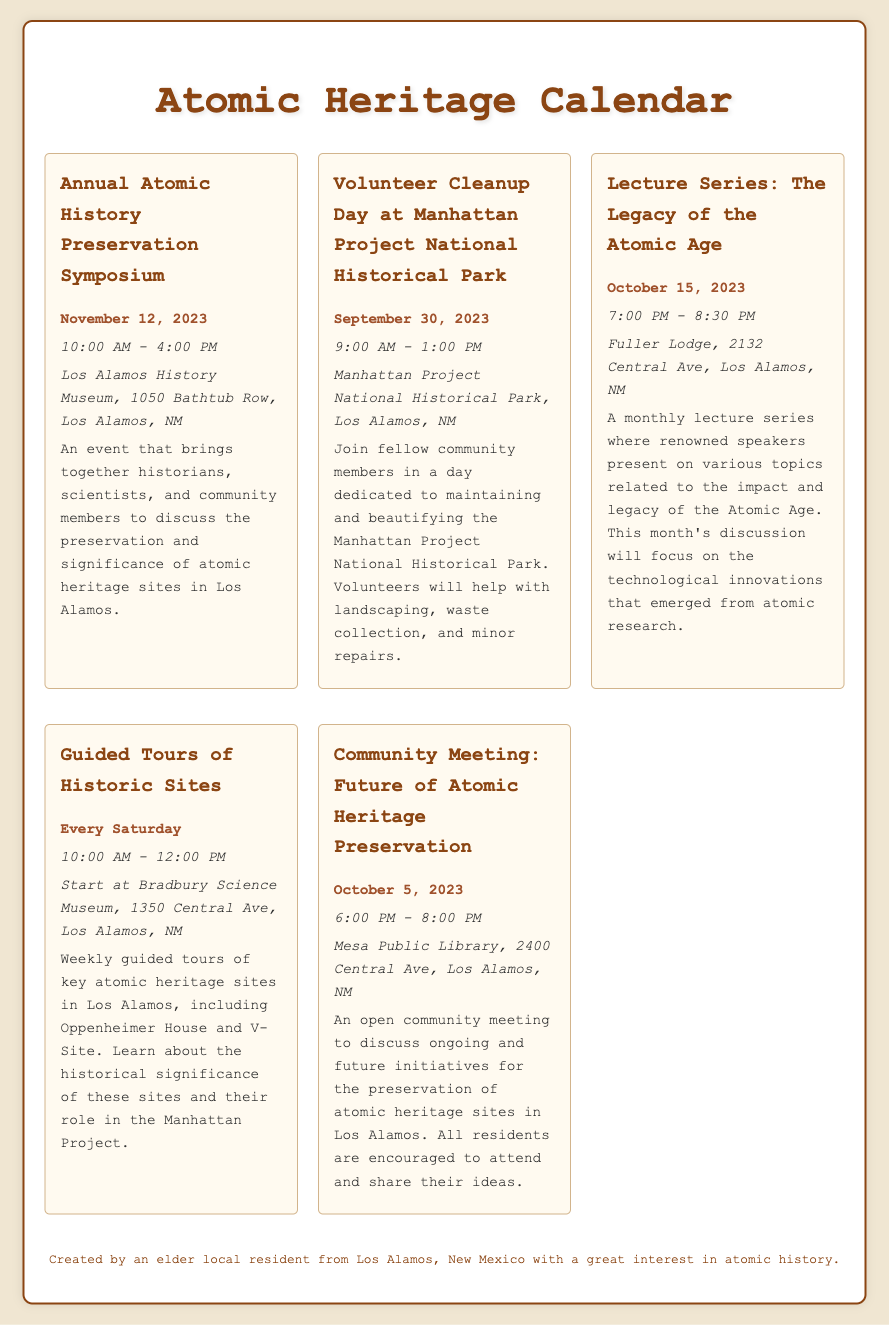What is the date of the Annual Atomic History Preservation Symposium? The date of the event is specifically mentioned in the document.
Answer: November 12, 2023 What time does the Volunteer Cleanup Day start? The time for the event is recorded in the document under its details.
Answer: 9:00 AM Where is the Community Meeting located? The location for the meeting is detailed in the event description.
Answer: Mesa Public Library, 2400 Central Ave, Los Alamos, NM How often are the Guided Tours of Historic Sites conducted? The document notes the frequency of these tours clearly.
Answer: Every Saturday What is being discussed in the Lecture Series on October 15, 2023? The document provides a summary of the topic for the lecture series in October.
Answer: Technological innovations that emerged from atomic research Which event involves beautifying the Manhattan Project National Historical Park? The document lists the specific event dedicated to this purpose.
Answer: Volunteer Cleanup Day at Manhattan Project National Historical Park How long does the Annual Atomic History Preservation Symposium last? The duration of the event is mentioned as part of the detailed schedule.
Answer: 6 hours What is the focus of the Community Meeting on October 5, 2023? The document summarizes the purpose of the community meeting, indicating its focus on preservation initiatives.
Answer: Future of Atomic Heritage Preservation 